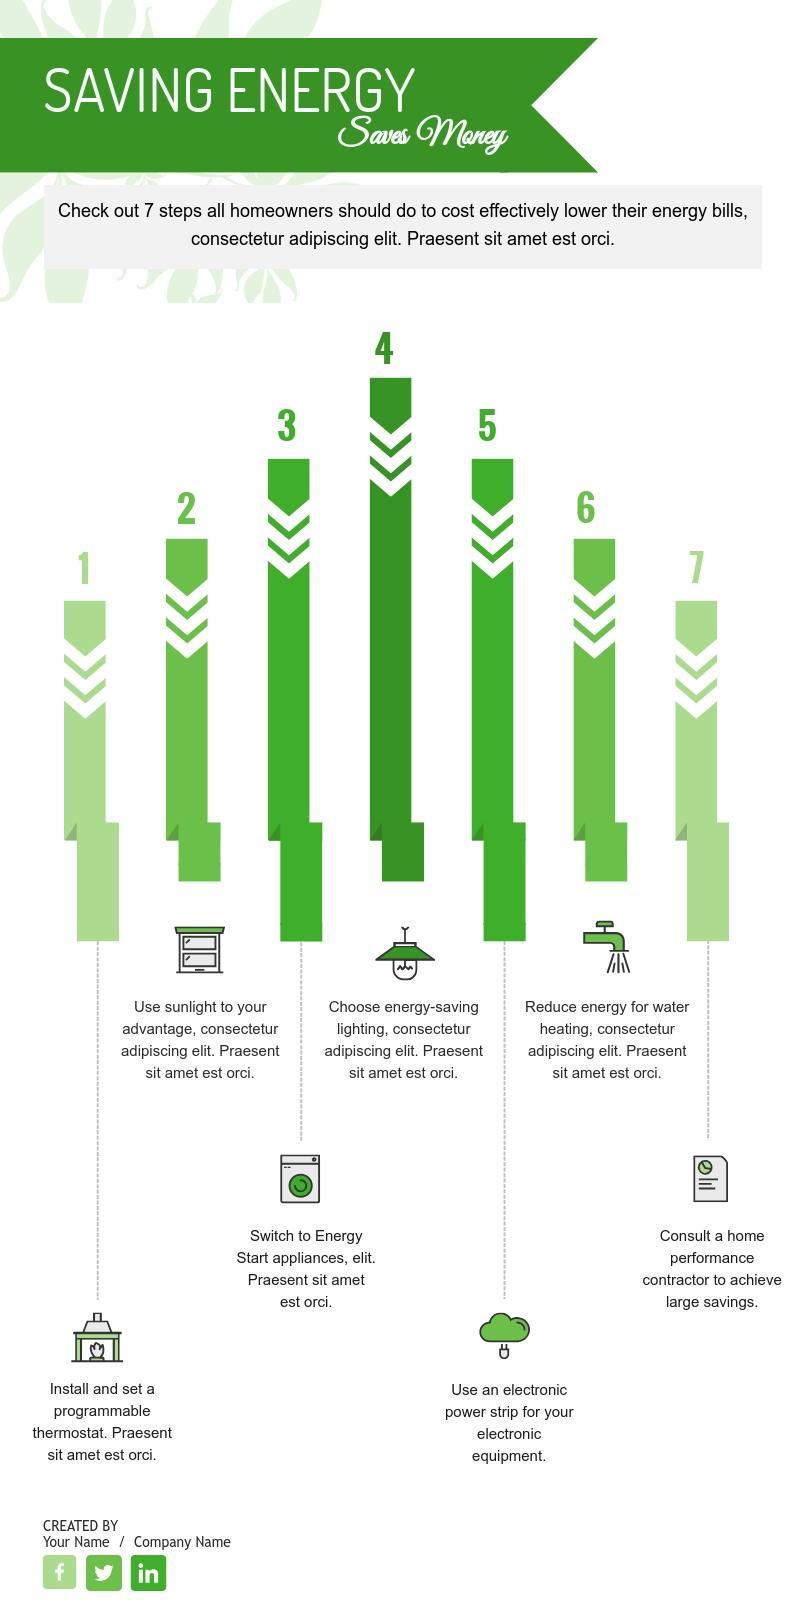what is the 5th step given to lower the energy bills?
Answer the question with a short phrase. use an electronic power strip for your electronic equipment what is the 7th step given to lower the energy bills? consult a home performance contractor to achieve large savings 